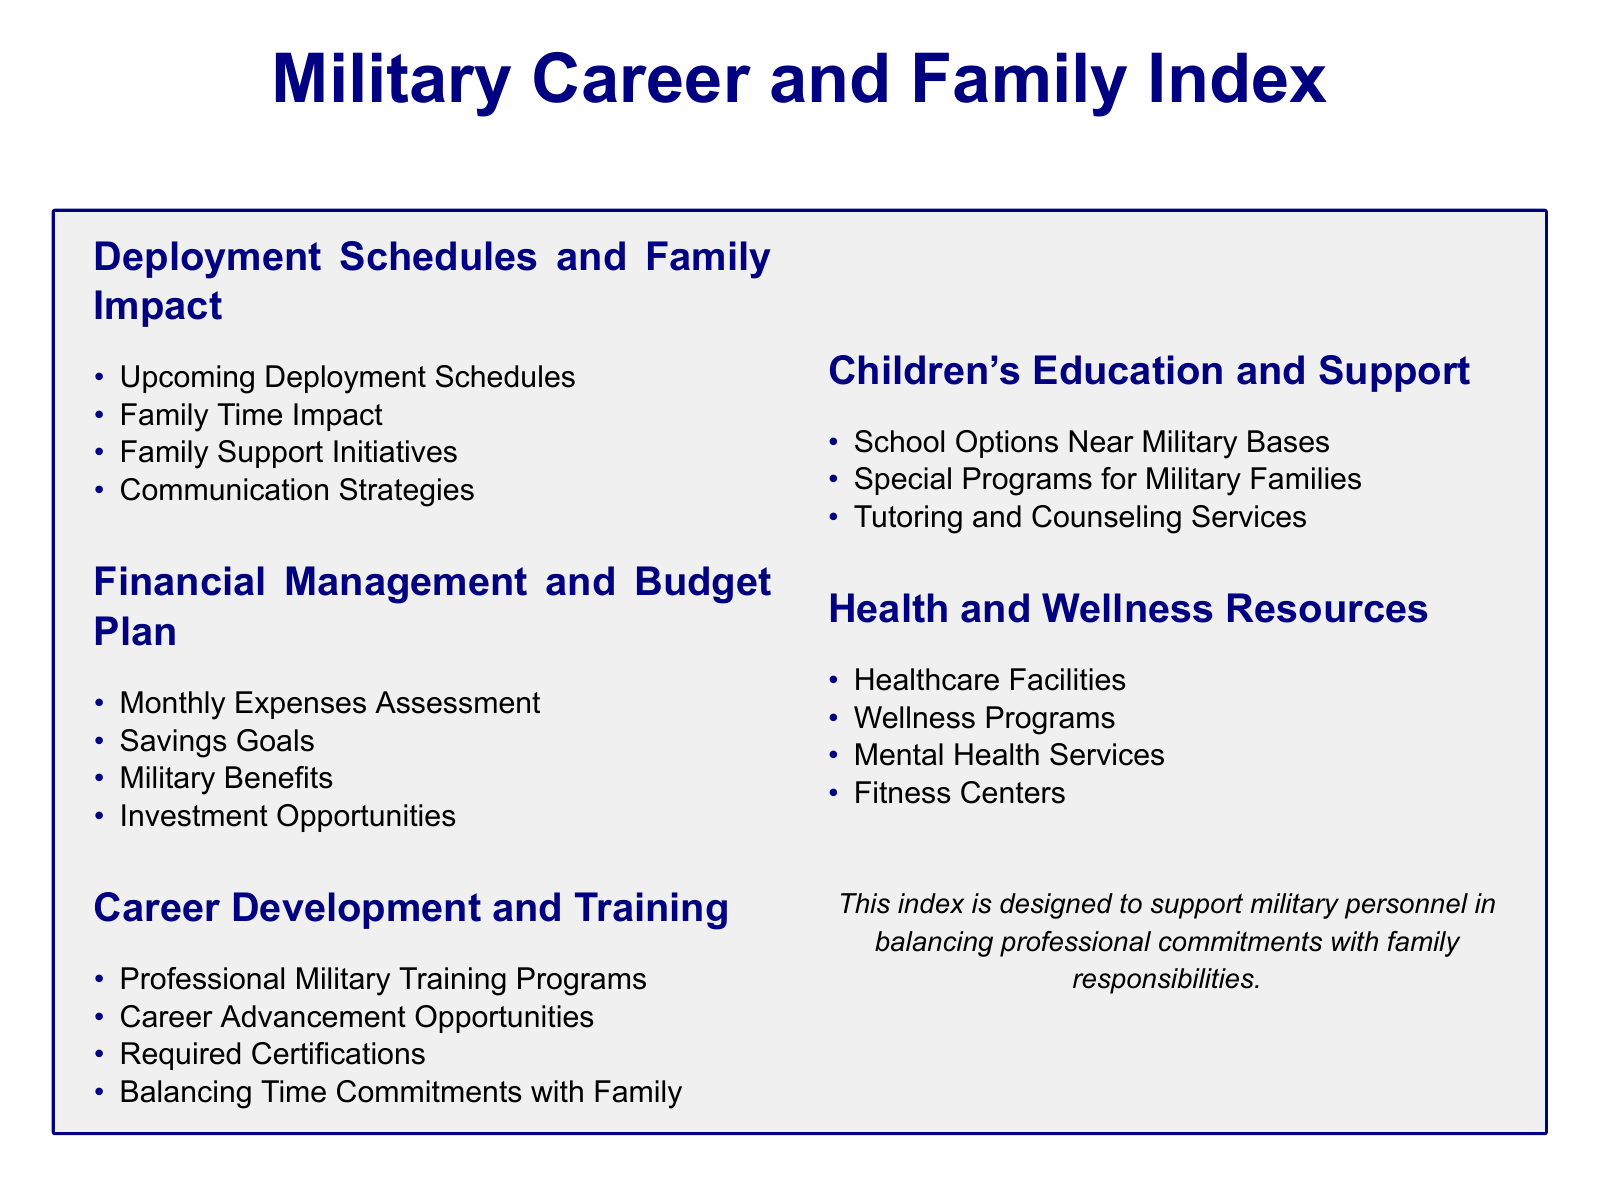What are the upcoming deployment schedules? The document outlines upcoming deployment schedules without specifying exact dates.
Answer: Upcoming Deployment Schedules What initiatives are planned to support families? The document references family support initiatives without detailing them.
Answer: Family Support Initiatives What type of training programs are mentioned? The document includes professional military training programs but does not specify individual programs.
Answer: Professional Military Training Programs What educational services are available for children? The document describes tutoring and counseling services without listing specific services.
Answer: Tutoring and Counseling Services What resources for mental health are listed? The document mentions mental health services but does not specify particular services.
Answer: Mental Health Services How can family commitments be balanced with career development? The document refers to balancing time commitments with family, indicating strategies may be discussed.
Answer: Balancing Time Commitments with Family What options are available for children's education near military bases? The document outlines school options near military bases but does not provide specific names.
Answer: School Options Near Military Bases What aspect of financial management is assessed? The document assesses monthly expenses as part of financial management.
Answer: Monthly Expenses Assessment Which wellness programs are discussed? The document states wellness programs without detailing specific programs.
Answer: Wellness Programs 